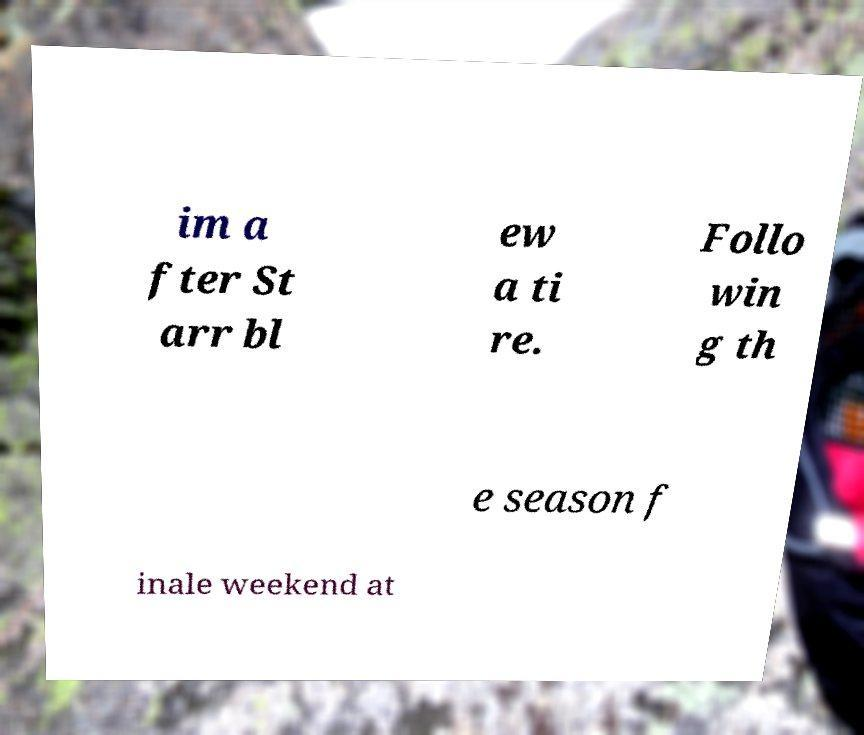Please read and relay the text visible in this image. What does it say? im a fter St arr bl ew a ti re. Follo win g th e season f inale weekend at 